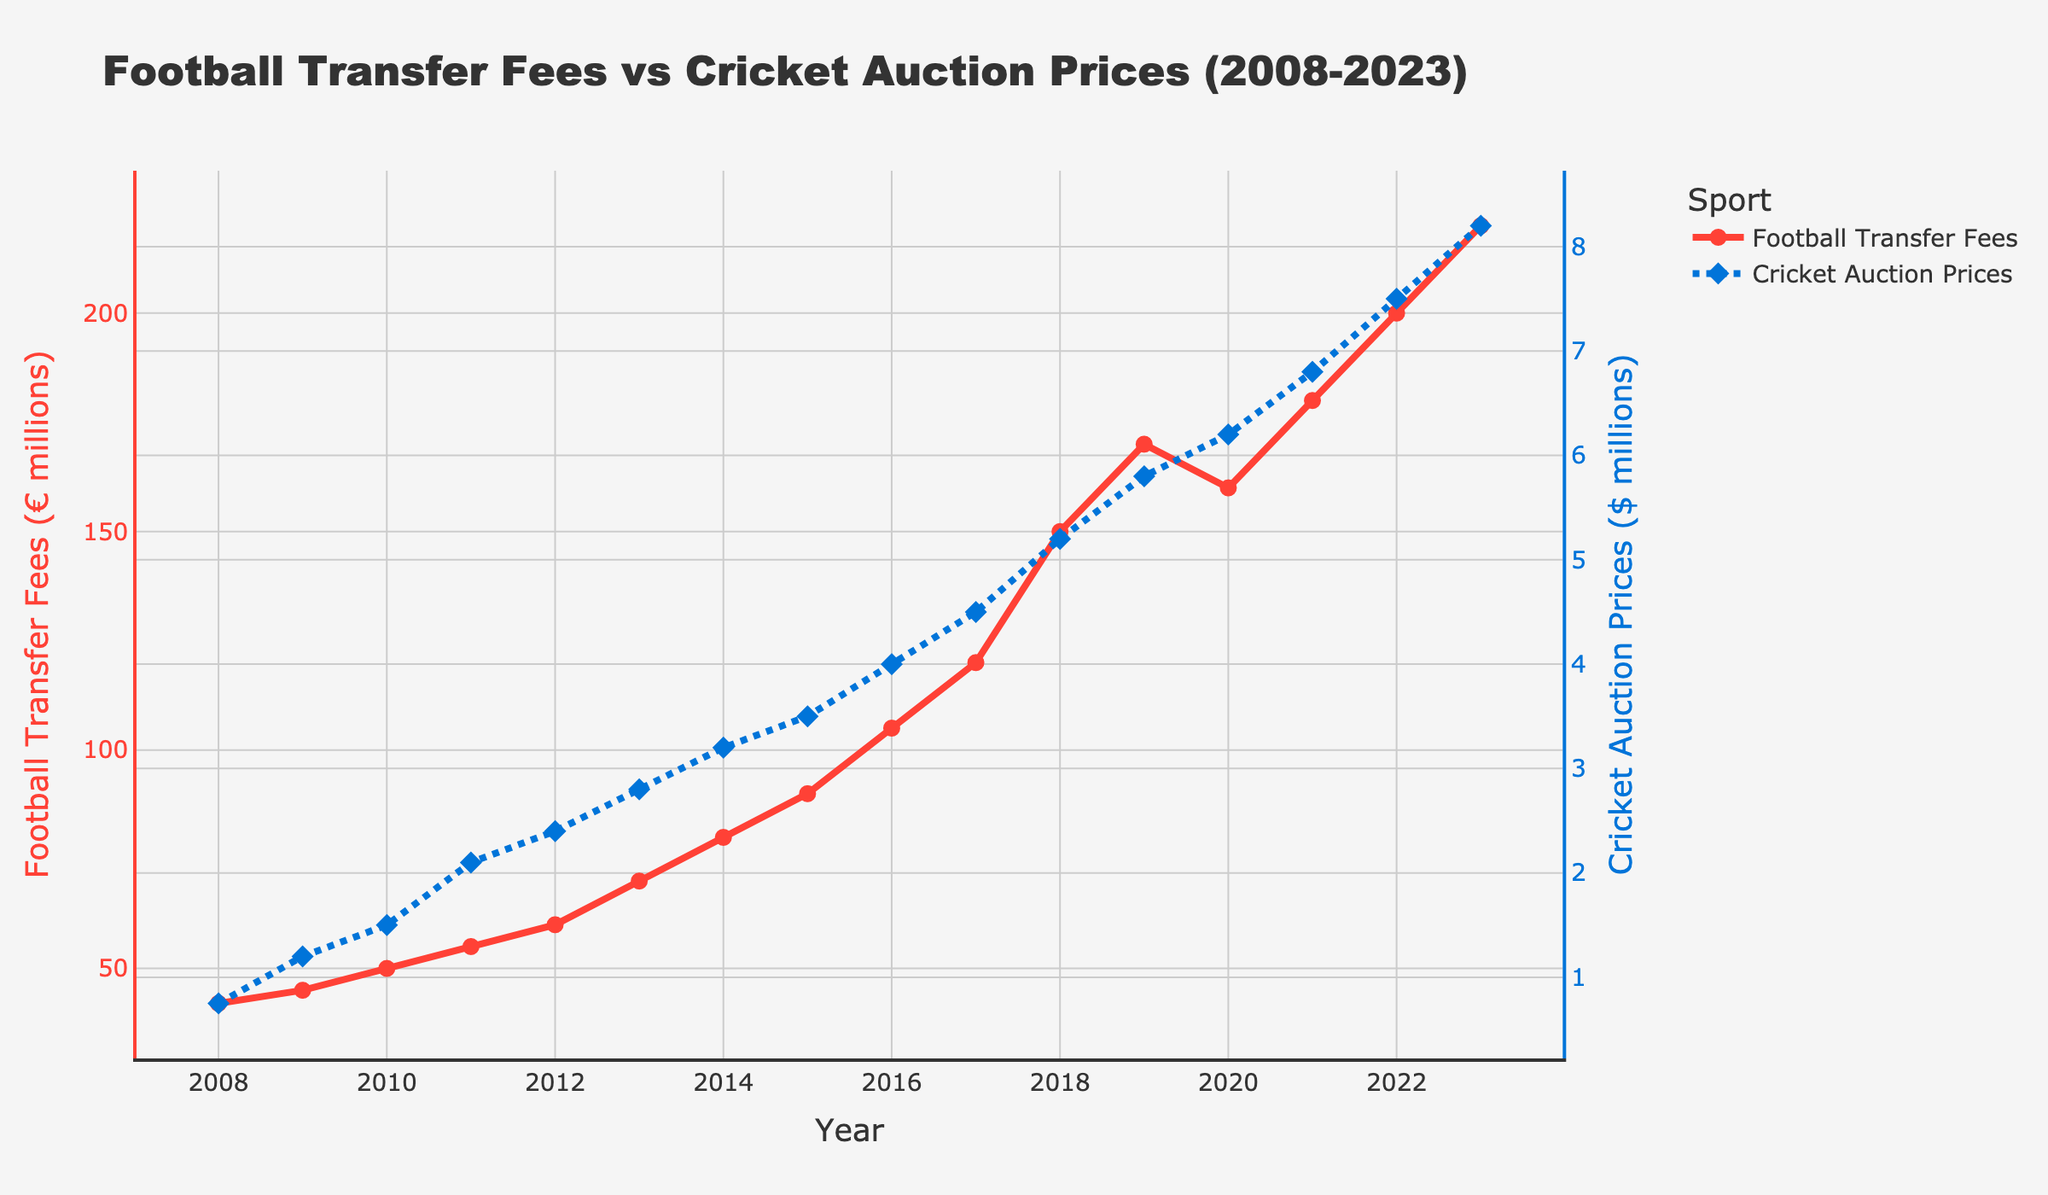What is the trend of Football Transfer Fees from 2008 to 2023? The Football Transfer Fees show a consistent upward trend from 42 million euros in 2008 to 220 million euros in 2023, with a small dip in 2020.
Answer: Upward trend Compare the overall increase in Football Transfer Fees with Cricket Auction Prices from 2008 to 2023. Football Transfer Fees increased from 42 million euros in 2008 to 220 million euros in 2023, an increase of 178 million euros. Cricket Auction Prices increased from 0.75 million dollars in 2008 to 8.2 million dollars in 2023, an increase of 7.45 million dollars.
Answer: Football Transfer Fees: 178 million euros, Cricket Auction Prices: 7.45 million dollars Which year witnessed the highest Football Transfer Fees? The figure shows that the highest Football Transfer Fees were in 2023, reaching 220 million euros.
Answer: 2023 What notable trend can you observe in Cricket Auction Prices around the year 2017? The Cricket Auction Prices rose significantly from 4.5 million dollars in 2017 to 5.2 million dollars in 2018, indicating a noticeable surge during that period.
Answer: Significant rise Which sport, Football Transfers or Cricket Auctions, shows a sharper rate of increase over the period shown? Looking at the slopes of both lines, the rate of increase is sharper for Football Transfer Fees as it shows a more dramatic rise compared to Cricket Auction Prices.
Answer: Football Transfers What year did both Football Transfer Fees and Cricket Auction Prices approximately double from their values in 2008? Football Transfer Fees were approximately 84 million euros in 2015, doubling from 42 million euros in 2008. Cricket Auction Prices were approximately 1.5 million dollars in 2010, doubling from 0.75 million dollars in 2008.
Answer: Football: 2015, Cricket: 2010 What is the difference between Football Transfer Fees and Cricket Auction Prices in 2023? In 2023, Football Transfer Fees are 220 million euros and Cricket Auction Prices are 8.2 million dollars. Converting dollars to euros hypothetically (assuming 1 USD = 0.85 EUR), Cricket Auction Prices are about 6.97 million euros. Therefore, the difference is 220 - 6.97 = 213.03 million euros.
Answer: 213.03 million euros By how much did Football Transfer Fees exceed Cricket Auction Prices in 2010? In 2010, Football Transfer Fees were 50 million euros and Cricket Auction Prices were 1.5 million dollars. Assuming 1 USD = 0.85 EUR, Cricket Auction Prices were about 1.275 million euros. The difference is 50 - 1.275 = 48.725 million euros.
Answer: 48.725 million euros What year shows the steepest increase in Football Transfer Fees? The steepest increase occurs between 2017 and 2018, where the values jump from 120 million euros in 2017 to 150 million euros in 2018, an increase of 30 million euros in one year.
Answer: 2017 to 2018 